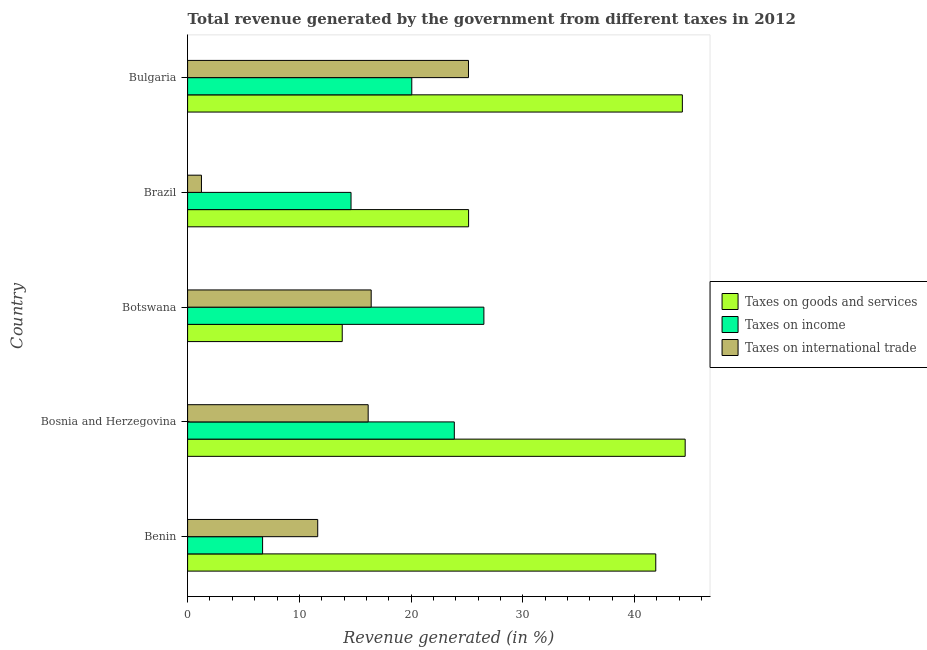How many groups of bars are there?
Make the answer very short. 5. Are the number of bars per tick equal to the number of legend labels?
Provide a succinct answer. Yes. How many bars are there on the 5th tick from the bottom?
Give a very brief answer. 3. What is the label of the 3rd group of bars from the top?
Provide a succinct answer. Botswana. In how many cases, is the number of bars for a given country not equal to the number of legend labels?
Give a very brief answer. 0. What is the percentage of revenue generated by taxes on income in Botswana?
Ensure brevity in your answer.  26.51. Across all countries, what is the maximum percentage of revenue generated by taxes on income?
Keep it short and to the point. 26.51. Across all countries, what is the minimum percentage of revenue generated by taxes on income?
Offer a very short reply. 6.71. In which country was the percentage of revenue generated by tax on international trade maximum?
Provide a succinct answer. Bulgaria. What is the total percentage of revenue generated by tax on international trade in the graph?
Your response must be concise. 70.6. What is the difference between the percentage of revenue generated by taxes on goods and services in Bosnia and Herzegovina and that in Bulgaria?
Your answer should be very brief. 0.25. What is the difference between the percentage of revenue generated by taxes on income in Bulgaria and the percentage of revenue generated by tax on international trade in Benin?
Offer a very short reply. 8.42. What is the average percentage of revenue generated by taxes on goods and services per country?
Give a very brief answer. 33.93. What is the difference between the percentage of revenue generated by tax on international trade and percentage of revenue generated by taxes on income in Brazil?
Your response must be concise. -13.38. In how many countries, is the percentage of revenue generated by taxes on income greater than 40 %?
Ensure brevity in your answer.  0. What is the ratio of the percentage of revenue generated by tax on international trade in Bosnia and Herzegovina to that in Brazil?
Ensure brevity in your answer.  13.03. Is the percentage of revenue generated by taxes on goods and services in Botswana less than that in Brazil?
Your response must be concise. Yes. What is the difference between the highest and the second highest percentage of revenue generated by tax on international trade?
Your response must be concise. 8.71. What is the difference between the highest and the lowest percentage of revenue generated by taxes on goods and services?
Offer a terse response. 30.69. What does the 3rd bar from the top in Bosnia and Herzegovina represents?
Your response must be concise. Taxes on goods and services. What does the 1st bar from the bottom in Bulgaria represents?
Your response must be concise. Taxes on goods and services. Is it the case that in every country, the sum of the percentage of revenue generated by taxes on goods and services and percentage of revenue generated by taxes on income is greater than the percentage of revenue generated by tax on international trade?
Provide a succinct answer. Yes. Are all the bars in the graph horizontal?
Offer a terse response. Yes. What is the difference between two consecutive major ticks on the X-axis?
Offer a terse response. 10. Are the values on the major ticks of X-axis written in scientific E-notation?
Provide a succinct answer. No. Does the graph contain any zero values?
Ensure brevity in your answer.  No. Does the graph contain grids?
Make the answer very short. No. How many legend labels are there?
Keep it short and to the point. 3. How are the legend labels stacked?
Ensure brevity in your answer.  Vertical. What is the title of the graph?
Provide a short and direct response. Total revenue generated by the government from different taxes in 2012. What is the label or title of the X-axis?
Offer a terse response. Revenue generated (in %). What is the label or title of the Y-axis?
Your answer should be very brief. Country. What is the Revenue generated (in %) in Taxes on goods and services in Benin?
Provide a succinct answer. 41.89. What is the Revenue generated (in %) in Taxes on income in Benin?
Ensure brevity in your answer.  6.71. What is the Revenue generated (in %) of Taxes on international trade in Benin?
Your response must be concise. 11.64. What is the Revenue generated (in %) of Taxes on goods and services in Bosnia and Herzegovina?
Your response must be concise. 44.52. What is the Revenue generated (in %) of Taxes on income in Bosnia and Herzegovina?
Your response must be concise. 23.87. What is the Revenue generated (in %) of Taxes on international trade in Bosnia and Herzegovina?
Provide a short and direct response. 16.16. What is the Revenue generated (in %) of Taxes on goods and services in Botswana?
Ensure brevity in your answer.  13.84. What is the Revenue generated (in %) of Taxes on income in Botswana?
Make the answer very short. 26.51. What is the Revenue generated (in %) in Taxes on international trade in Botswana?
Keep it short and to the point. 16.43. What is the Revenue generated (in %) of Taxes on goods and services in Brazil?
Offer a terse response. 25.14. What is the Revenue generated (in %) of Taxes on income in Brazil?
Provide a short and direct response. 14.62. What is the Revenue generated (in %) of Taxes on international trade in Brazil?
Ensure brevity in your answer.  1.24. What is the Revenue generated (in %) in Taxes on goods and services in Bulgaria?
Make the answer very short. 44.27. What is the Revenue generated (in %) of Taxes on income in Bulgaria?
Provide a succinct answer. 20.06. What is the Revenue generated (in %) of Taxes on international trade in Bulgaria?
Give a very brief answer. 25.13. Across all countries, what is the maximum Revenue generated (in %) of Taxes on goods and services?
Make the answer very short. 44.52. Across all countries, what is the maximum Revenue generated (in %) of Taxes on income?
Give a very brief answer. 26.51. Across all countries, what is the maximum Revenue generated (in %) of Taxes on international trade?
Your answer should be very brief. 25.13. Across all countries, what is the minimum Revenue generated (in %) of Taxes on goods and services?
Provide a short and direct response. 13.84. Across all countries, what is the minimum Revenue generated (in %) in Taxes on income?
Ensure brevity in your answer.  6.71. Across all countries, what is the minimum Revenue generated (in %) in Taxes on international trade?
Make the answer very short. 1.24. What is the total Revenue generated (in %) of Taxes on goods and services in the graph?
Ensure brevity in your answer.  169.66. What is the total Revenue generated (in %) in Taxes on income in the graph?
Offer a terse response. 91.77. What is the total Revenue generated (in %) in Taxes on international trade in the graph?
Ensure brevity in your answer.  70.6. What is the difference between the Revenue generated (in %) in Taxes on goods and services in Benin and that in Bosnia and Herzegovina?
Your response must be concise. -2.63. What is the difference between the Revenue generated (in %) in Taxes on income in Benin and that in Bosnia and Herzegovina?
Offer a terse response. -17.15. What is the difference between the Revenue generated (in %) of Taxes on international trade in Benin and that in Bosnia and Herzegovina?
Give a very brief answer. -4.51. What is the difference between the Revenue generated (in %) in Taxes on goods and services in Benin and that in Botswana?
Make the answer very short. 28.05. What is the difference between the Revenue generated (in %) in Taxes on income in Benin and that in Botswana?
Ensure brevity in your answer.  -19.8. What is the difference between the Revenue generated (in %) of Taxes on international trade in Benin and that in Botswana?
Your answer should be very brief. -4.78. What is the difference between the Revenue generated (in %) in Taxes on goods and services in Benin and that in Brazil?
Your answer should be compact. 16.75. What is the difference between the Revenue generated (in %) of Taxes on income in Benin and that in Brazil?
Offer a very short reply. -7.91. What is the difference between the Revenue generated (in %) of Taxes on international trade in Benin and that in Brazil?
Keep it short and to the point. 10.4. What is the difference between the Revenue generated (in %) in Taxes on goods and services in Benin and that in Bulgaria?
Your response must be concise. -2.38. What is the difference between the Revenue generated (in %) in Taxes on income in Benin and that in Bulgaria?
Give a very brief answer. -13.35. What is the difference between the Revenue generated (in %) in Taxes on international trade in Benin and that in Bulgaria?
Ensure brevity in your answer.  -13.49. What is the difference between the Revenue generated (in %) of Taxes on goods and services in Bosnia and Herzegovina and that in Botswana?
Offer a very short reply. 30.69. What is the difference between the Revenue generated (in %) in Taxes on income in Bosnia and Herzegovina and that in Botswana?
Offer a terse response. -2.65. What is the difference between the Revenue generated (in %) of Taxes on international trade in Bosnia and Herzegovina and that in Botswana?
Ensure brevity in your answer.  -0.27. What is the difference between the Revenue generated (in %) of Taxes on goods and services in Bosnia and Herzegovina and that in Brazil?
Keep it short and to the point. 19.38. What is the difference between the Revenue generated (in %) of Taxes on income in Bosnia and Herzegovina and that in Brazil?
Make the answer very short. 9.24. What is the difference between the Revenue generated (in %) in Taxes on international trade in Bosnia and Herzegovina and that in Brazil?
Your response must be concise. 14.92. What is the difference between the Revenue generated (in %) in Taxes on goods and services in Bosnia and Herzegovina and that in Bulgaria?
Your answer should be very brief. 0.25. What is the difference between the Revenue generated (in %) of Taxes on income in Bosnia and Herzegovina and that in Bulgaria?
Provide a succinct answer. 3.81. What is the difference between the Revenue generated (in %) in Taxes on international trade in Bosnia and Herzegovina and that in Bulgaria?
Your answer should be compact. -8.98. What is the difference between the Revenue generated (in %) in Taxes on goods and services in Botswana and that in Brazil?
Your answer should be very brief. -11.31. What is the difference between the Revenue generated (in %) of Taxes on income in Botswana and that in Brazil?
Ensure brevity in your answer.  11.89. What is the difference between the Revenue generated (in %) of Taxes on international trade in Botswana and that in Brazil?
Your answer should be very brief. 15.19. What is the difference between the Revenue generated (in %) of Taxes on goods and services in Botswana and that in Bulgaria?
Ensure brevity in your answer.  -30.43. What is the difference between the Revenue generated (in %) of Taxes on income in Botswana and that in Bulgaria?
Make the answer very short. 6.45. What is the difference between the Revenue generated (in %) in Taxes on international trade in Botswana and that in Bulgaria?
Your answer should be compact. -8.71. What is the difference between the Revenue generated (in %) in Taxes on goods and services in Brazil and that in Bulgaria?
Your answer should be compact. -19.13. What is the difference between the Revenue generated (in %) of Taxes on income in Brazil and that in Bulgaria?
Provide a succinct answer. -5.44. What is the difference between the Revenue generated (in %) of Taxes on international trade in Brazil and that in Bulgaria?
Provide a short and direct response. -23.89. What is the difference between the Revenue generated (in %) of Taxes on goods and services in Benin and the Revenue generated (in %) of Taxes on income in Bosnia and Herzegovina?
Make the answer very short. 18.03. What is the difference between the Revenue generated (in %) in Taxes on goods and services in Benin and the Revenue generated (in %) in Taxes on international trade in Bosnia and Herzegovina?
Provide a succinct answer. 25.73. What is the difference between the Revenue generated (in %) in Taxes on income in Benin and the Revenue generated (in %) in Taxes on international trade in Bosnia and Herzegovina?
Offer a terse response. -9.45. What is the difference between the Revenue generated (in %) of Taxes on goods and services in Benin and the Revenue generated (in %) of Taxes on income in Botswana?
Offer a very short reply. 15.38. What is the difference between the Revenue generated (in %) in Taxes on goods and services in Benin and the Revenue generated (in %) in Taxes on international trade in Botswana?
Your response must be concise. 25.46. What is the difference between the Revenue generated (in %) in Taxes on income in Benin and the Revenue generated (in %) in Taxes on international trade in Botswana?
Make the answer very short. -9.72. What is the difference between the Revenue generated (in %) in Taxes on goods and services in Benin and the Revenue generated (in %) in Taxes on income in Brazil?
Your response must be concise. 27.27. What is the difference between the Revenue generated (in %) in Taxes on goods and services in Benin and the Revenue generated (in %) in Taxes on international trade in Brazil?
Your answer should be very brief. 40.65. What is the difference between the Revenue generated (in %) of Taxes on income in Benin and the Revenue generated (in %) of Taxes on international trade in Brazil?
Provide a succinct answer. 5.47. What is the difference between the Revenue generated (in %) in Taxes on goods and services in Benin and the Revenue generated (in %) in Taxes on income in Bulgaria?
Your answer should be compact. 21.83. What is the difference between the Revenue generated (in %) of Taxes on goods and services in Benin and the Revenue generated (in %) of Taxes on international trade in Bulgaria?
Ensure brevity in your answer.  16.76. What is the difference between the Revenue generated (in %) in Taxes on income in Benin and the Revenue generated (in %) in Taxes on international trade in Bulgaria?
Offer a very short reply. -18.42. What is the difference between the Revenue generated (in %) of Taxes on goods and services in Bosnia and Herzegovina and the Revenue generated (in %) of Taxes on income in Botswana?
Offer a very short reply. 18.01. What is the difference between the Revenue generated (in %) in Taxes on goods and services in Bosnia and Herzegovina and the Revenue generated (in %) in Taxes on international trade in Botswana?
Offer a terse response. 28.1. What is the difference between the Revenue generated (in %) in Taxes on income in Bosnia and Herzegovina and the Revenue generated (in %) in Taxes on international trade in Botswana?
Provide a short and direct response. 7.44. What is the difference between the Revenue generated (in %) in Taxes on goods and services in Bosnia and Herzegovina and the Revenue generated (in %) in Taxes on income in Brazil?
Keep it short and to the point. 29.9. What is the difference between the Revenue generated (in %) in Taxes on goods and services in Bosnia and Herzegovina and the Revenue generated (in %) in Taxes on international trade in Brazil?
Your response must be concise. 43.28. What is the difference between the Revenue generated (in %) of Taxes on income in Bosnia and Herzegovina and the Revenue generated (in %) of Taxes on international trade in Brazil?
Your response must be concise. 22.63. What is the difference between the Revenue generated (in %) in Taxes on goods and services in Bosnia and Herzegovina and the Revenue generated (in %) in Taxes on income in Bulgaria?
Provide a short and direct response. 24.46. What is the difference between the Revenue generated (in %) in Taxes on goods and services in Bosnia and Herzegovina and the Revenue generated (in %) in Taxes on international trade in Bulgaria?
Keep it short and to the point. 19.39. What is the difference between the Revenue generated (in %) of Taxes on income in Bosnia and Herzegovina and the Revenue generated (in %) of Taxes on international trade in Bulgaria?
Keep it short and to the point. -1.27. What is the difference between the Revenue generated (in %) of Taxes on goods and services in Botswana and the Revenue generated (in %) of Taxes on income in Brazil?
Provide a succinct answer. -0.79. What is the difference between the Revenue generated (in %) in Taxes on goods and services in Botswana and the Revenue generated (in %) in Taxes on international trade in Brazil?
Keep it short and to the point. 12.6. What is the difference between the Revenue generated (in %) of Taxes on income in Botswana and the Revenue generated (in %) of Taxes on international trade in Brazil?
Give a very brief answer. 25.27. What is the difference between the Revenue generated (in %) of Taxes on goods and services in Botswana and the Revenue generated (in %) of Taxes on income in Bulgaria?
Offer a terse response. -6.22. What is the difference between the Revenue generated (in %) of Taxes on goods and services in Botswana and the Revenue generated (in %) of Taxes on international trade in Bulgaria?
Your answer should be very brief. -11.3. What is the difference between the Revenue generated (in %) of Taxes on income in Botswana and the Revenue generated (in %) of Taxes on international trade in Bulgaria?
Offer a very short reply. 1.38. What is the difference between the Revenue generated (in %) of Taxes on goods and services in Brazil and the Revenue generated (in %) of Taxes on income in Bulgaria?
Provide a short and direct response. 5.08. What is the difference between the Revenue generated (in %) of Taxes on goods and services in Brazil and the Revenue generated (in %) of Taxes on international trade in Bulgaria?
Your response must be concise. 0.01. What is the difference between the Revenue generated (in %) in Taxes on income in Brazil and the Revenue generated (in %) in Taxes on international trade in Bulgaria?
Offer a terse response. -10.51. What is the average Revenue generated (in %) in Taxes on goods and services per country?
Offer a very short reply. 33.93. What is the average Revenue generated (in %) of Taxes on income per country?
Give a very brief answer. 18.35. What is the average Revenue generated (in %) in Taxes on international trade per country?
Give a very brief answer. 14.12. What is the difference between the Revenue generated (in %) in Taxes on goods and services and Revenue generated (in %) in Taxes on income in Benin?
Offer a terse response. 35.18. What is the difference between the Revenue generated (in %) in Taxes on goods and services and Revenue generated (in %) in Taxes on international trade in Benin?
Provide a short and direct response. 30.25. What is the difference between the Revenue generated (in %) in Taxes on income and Revenue generated (in %) in Taxes on international trade in Benin?
Give a very brief answer. -4.93. What is the difference between the Revenue generated (in %) of Taxes on goods and services and Revenue generated (in %) of Taxes on income in Bosnia and Herzegovina?
Your answer should be very brief. 20.66. What is the difference between the Revenue generated (in %) of Taxes on goods and services and Revenue generated (in %) of Taxes on international trade in Bosnia and Herzegovina?
Your response must be concise. 28.37. What is the difference between the Revenue generated (in %) of Taxes on income and Revenue generated (in %) of Taxes on international trade in Bosnia and Herzegovina?
Offer a very short reply. 7.71. What is the difference between the Revenue generated (in %) in Taxes on goods and services and Revenue generated (in %) in Taxes on income in Botswana?
Offer a very short reply. -12.68. What is the difference between the Revenue generated (in %) of Taxes on goods and services and Revenue generated (in %) of Taxes on international trade in Botswana?
Your answer should be very brief. -2.59. What is the difference between the Revenue generated (in %) of Taxes on income and Revenue generated (in %) of Taxes on international trade in Botswana?
Provide a succinct answer. 10.09. What is the difference between the Revenue generated (in %) in Taxes on goods and services and Revenue generated (in %) in Taxes on income in Brazil?
Offer a very short reply. 10.52. What is the difference between the Revenue generated (in %) of Taxes on goods and services and Revenue generated (in %) of Taxes on international trade in Brazil?
Offer a terse response. 23.9. What is the difference between the Revenue generated (in %) in Taxes on income and Revenue generated (in %) in Taxes on international trade in Brazil?
Provide a short and direct response. 13.38. What is the difference between the Revenue generated (in %) of Taxes on goods and services and Revenue generated (in %) of Taxes on income in Bulgaria?
Provide a succinct answer. 24.21. What is the difference between the Revenue generated (in %) in Taxes on goods and services and Revenue generated (in %) in Taxes on international trade in Bulgaria?
Ensure brevity in your answer.  19.14. What is the difference between the Revenue generated (in %) in Taxes on income and Revenue generated (in %) in Taxes on international trade in Bulgaria?
Offer a terse response. -5.07. What is the ratio of the Revenue generated (in %) in Taxes on goods and services in Benin to that in Bosnia and Herzegovina?
Your answer should be compact. 0.94. What is the ratio of the Revenue generated (in %) in Taxes on income in Benin to that in Bosnia and Herzegovina?
Offer a terse response. 0.28. What is the ratio of the Revenue generated (in %) of Taxes on international trade in Benin to that in Bosnia and Herzegovina?
Your response must be concise. 0.72. What is the ratio of the Revenue generated (in %) in Taxes on goods and services in Benin to that in Botswana?
Provide a short and direct response. 3.03. What is the ratio of the Revenue generated (in %) of Taxes on income in Benin to that in Botswana?
Offer a very short reply. 0.25. What is the ratio of the Revenue generated (in %) in Taxes on international trade in Benin to that in Botswana?
Your answer should be very brief. 0.71. What is the ratio of the Revenue generated (in %) in Taxes on goods and services in Benin to that in Brazil?
Provide a short and direct response. 1.67. What is the ratio of the Revenue generated (in %) of Taxes on income in Benin to that in Brazil?
Your response must be concise. 0.46. What is the ratio of the Revenue generated (in %) in Taxes on international trade in Benin to that in Brazil?
Give a very brief answer. 9.39. What is the ratio of the Revenue generated (in %) of Taxes on goods and services in Benin to that in Bulgaria?
Provide a short and direct response. 0.95. What is the ratio of the Revenue generated (in %) in Taxes on income in Benin to that in Bulgaria?
Your answer should be very brief. 0.33. What is the ratio of the Revenue generated (in %) of Taxes on international trade in Benin to that in Bulgaria?
Keep it short and to the point. 0.46. What is the ratio of the Revenue generated (in %) of Taxes on goods and services in Bosnia and Herzegovina to that in Botswana?
Ensure brevity in your answer.  3.22. What is the ratio of the Revenue generated (in %) in Taxes on income in Bosnia and Herzegovina to that in Botswana?
Provide a short and direct response. 0.9. What is the ratio of the Revenue generated (in %) in Taxes on international trade in Bosnia and Herzegovina to that in Botswana?
Ensure brevity in your answer.  0.98. What is the ratio of the Revenue generated (in %) in Taxes on goods and services in Bosnia and Herzegovina to that in Brazil?
Keep it short and to the point. 1.77. What is the ratio of the Revenue generated (in %) of Taxes on income in Bosnia and Herzegovina to that in Brazil?
Make the answer very short. 1.63. What is the ratio of the Revenue generated (in %) in Taxes on international trade in Bosnia and Herzegovina to that in Brazil?
Give a very brief answer. 13.03. What is the ratio of the Revenue generated (in %) in Taxes on income in Bosnia and Herzegovina to that in Bulgaria?
Provide a short and direct response. 1.19. What is the ratio of the Revenue generated (in %) of Taxes on international trade in Bosnia and Herzegovina to that in Bulgaria?
Your answer should be very brief. 0.64. What is the ratio of the Revenue generated (in %) of Taxes on goods and services in Botswana to that in Brazil?
Ensure brevity in your answer.  0.55. What is the ratio of the Revenue generated (in %) of Taxes on income in Botswana to that in Brazil?
Provide a short and direct response. 1.81. What is the ratio of the Revenue generated (in %) of Taxes on international trade in Botswana to that in Brazil?
Keep it short and to the point. 13.25. What is the ratio of the Revenue generated (in %) of Taxes on goods and services in Botswana to that in Bulgaria?
Provide a succinct answer. 0.31. What is the ratio of the Revenue generated (in %) of Taxes on income in Botswana to that in Bulgaria?
Your response must be concise. 1.32. What is the ratio of the Revenue generated (in %) in Taxes on international trade in Botswana to that in Bulgaria?
Your answer should be compact. 0.65. What is the ratio of the Revenue generated (in %) in Taxes on goods and services in Brazil to that in Bulgaria?
Provide a succinct answer. 0.57. What is the ratio of the Revenue generated (in %) in Taxes on income in Brazil to that in Bulgaria?
Offer a very short reply. 0.73. What is the ratio of the Revenue generated (in %) in Taxes on international trade in Brazil to that in Bulgaria?
Give a very brief answer. 0.05. What is the difference between the highest and the second highest Revenue generated (in %) of Taxes on goods and services?
Your answer should be compact. 0.25. What is the difference between the highest and the second highest Revenue generated (in %) in Taxes on income?
Keep it short and to the point. 2.65. What is the difference between the highest and the second highest Revenue generated (in %) in Taxes on international trade?
Give a very brief answer. 8.71. What is the difference between the highest and the lowest Revenue generated (in %) in Taxes on goods and services?
Keep it short and to the point. 30.69. What is the difference between the highest and the lowest Revenue generated (in %) in Taxes on income?
Provide a succinct answer. 19.8. What is the difference between the highest and the lowest Revenue generated (in %) in Taxes on international trade?
Provide a short and direct response. 23.89. 